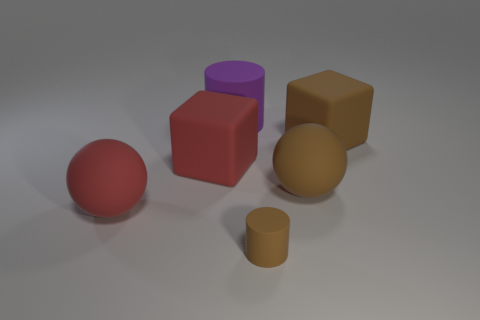Are there any red matte balls right of the ball that is to the right of the large rubber ball that is to the left of the tiny rubber cylinder?
Make the answer very short. No. What shape is the red object that is the same size as the red sphere?
Your answer should be very brief. Cube. Does the red rubber sphere that is in front of the purple cylinder have the same size as the matte block on the right side of the big brown sphere?
Provide a short and direct response. Yes. How many large red metallic blocks are there?
Your answer should be very brief. 0. How big is the brown rubber thing in front of the matte sphere that is to the right of the large sphere that is left of the brown cylinder?
Keep it short and to the point. Small. Is the color of the large cylinder the same as the small object?
Your response must be concise. No. Is there anything else that is the same size as the purple cylinder?
Your answer should be compact. Yes. How many rubber cubes are on the right side of the red ball?
Ensure brevity in your answer.  2. Are there the same number of red matte things that are behind the large purple rubber thing and large brown metal objects?
Keep it short and to the point. Yes. How many things are either big red cubes or big purple matte things?
Offer a terse response. 2. 